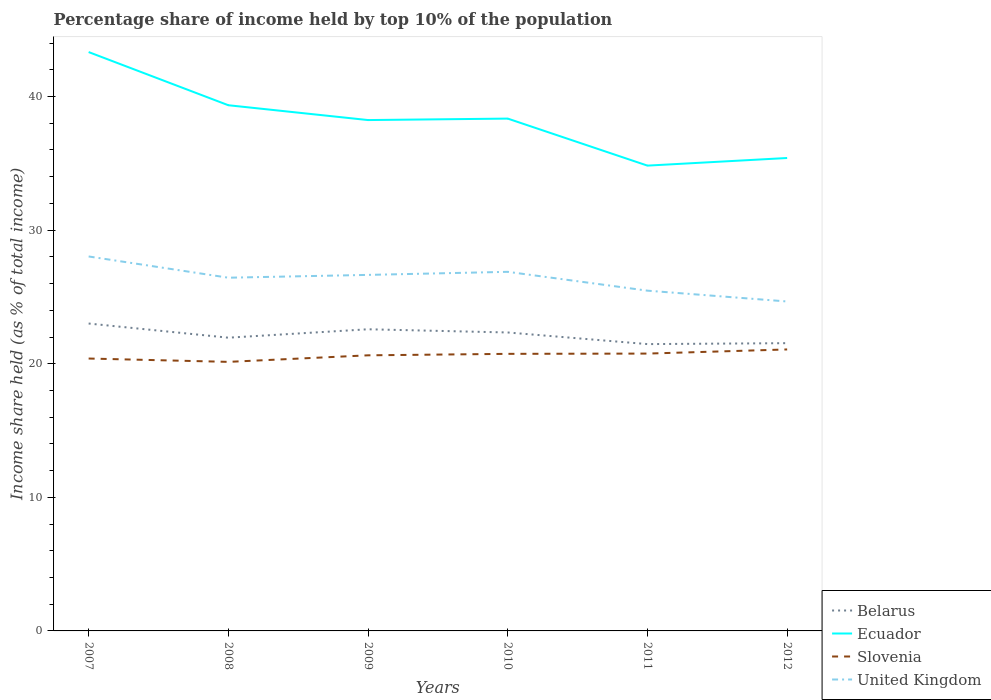How many different coloured lines are there?
Your response must be concise. 4. Does the line corresponding to Belarus intersect with the line corresponding to Ecuador?
Keep it short and to the point. No. Is the number of lines equal to the number of legend labels?
Your answer should be very brief. Yes. Across all years, what is the maximum percentage share of income held by top 10% of the population in United Kingdom?
Give a very brief answer. 24.66. In which year was the percentage share of income held by top 10% of the population in Belarus maximum?
Your response must be concise. 2011. What is the total percentage share of income held by top 10% of the population in Ecuador in the graph?
Give a very brief answer. 8.5. What is the difference between the highest and the second highest percentage share of income held by top 10% of the population in Belarus?
Provide a short and direct response. 1.54. What is the difference between the highest and the lowest percentage share of income held by top 10% of the population in Belarus?
Offer a terse response. 3. Is the percentage share of income held by top 10% of the population in Ecuador strictly greater than the percentage share of income held by top 10% of the population in Belarus over the years?
Make the answer very short. No. How many years are there in the graph?
Make the answer very short. 6. Are the values on the major ticks of Y-axis written in scientific E-notation?
Provide a short and direct response. No. Does the graph contain any zero values?
Offer a terse response. No. Does the graph contain grids?
Your answer should be compact. No. Where does the legend appear in the graph?
Your answer should be very brief. Bottom right. How many legend labels are there?
Your answer should be compact. 4. What is the title of the graph?
Ensure brevity in your answer.  Percentage share of income held by top 10% of the population. Does "Niger" appear as one of the legend labels in the graph?
Offer a terse response. No. What is the label or title of the X-axis?
Your answer should be compact. Years. What is the label or title of the Y-axis?
Offer a terse response. Income share held (as % of total income). What is the Income share held (as % of total income) in Belarus in 2007?
Provide a succinct answer. 23.01. What is the Income share held (as % of total income) in Ecuador in 2007?
Your answer should be very brief. 43.33. What is the Income share held (as % of total income) of Slovenia in 2007?
Your response must be concise. 20.39. What is the Income share held (as % of total income) of United Kingdom in 2007?
Provide a short and direct response. 28.03. What is the Income share held (as % of total income) of Belarus in 2008?
Make the answer very short. 21.95. What is the Income share held (as % of total income) of Ecuador in 2008?
Provide a short and direct response. 39.35. What is the Income share held (as % of total income) in Slovenia in 2008?
Offer a very short reply. 20.14. What is the Income share held (as % of total income) in United Kingdom in 2008?
Ensure brevity in your answer.  26.44. What is the Income share held (as % of total income) in Belarus in 2009?
Your response must be concise. 22.58. What is the Income share held (as % of total income) of Ecuador in 2009?
Offer a terse response. 38.24. What is the Income share held (as % of total income) in Slovenia in 2009?
Give a very brief answer. 20.63. What is the Income share held (as % of total income) of United Kingdom in 2009?
Offer a terse response. 26.65. What is the Income share held (as % of total income) of Belarus in 2010?
Offer a terse response. 22.34. What is the Income share held (as % of total income) in Ecuador in 2010?
Offer a terse response. 38.35. What is the Income share held (as % of total income) of Slovenia in 2010?
Your response must be concise. 20.74. What is the Income share held (as % of total income) of United Kingdom in 2010?
Your answer should be compact. 26.88. What is the Income share held (as % of total income) of Belarus in 2011?
Give a very brief answer. 21.47. What is the Income share held (as % of total income) in Ecuador in 2011?
Offer a terse response. 34.83. What is the Income share held (as % of total income) in Slovenia in 2011?
Give a very brief answer. 20.76. What is the Income share held (as % of total income) in United Kingdom in 2011?
Provide a succinct answer. 25.47. What is the Income share held (as % of total income) in Belarus in 2012?
Your answer should be very brief. 21.54. What is the Income share held (as % of total income) of Ecuador in 2012?
Keep it short and to the point. 35.4. What is the Income share held (as % of total income) in Slovenia in 2012?
Make the answer very short. 21.07. What is the Income share held (as % of total income) of United Kingdom in 2012?
Provide a short and direct response. 24.66. Across all years, what is the maximum Income share held (as % of total income) in Belarus?
Keep it short and to the point. 23.01. Across all years, what is the maximum Income share held (as % of total income) in Ecuador?
Offer a terse response. 43.33. Across all years, what is the maximum Income share held (as % of total income) in Slovenia?
Your answer should be very brief. 21.07. Across all years, what is the maximum Income share held (as % of total income) of United Kingdom?
Provide a succinct answer. 28.03. Across all years, what is the minimum Income share held (as % of total income) of Belarus?
Give a very brief answer. 21.47. Across all years, what is the minimum Income share held (as % of total income) of Ecuador?
Offer a terse response. 34.83. Across all years, what is the minimum Income share held (as % of total income) of Slovenia?
Your answer should be very brief. 20.14. Across all years, what is the minimum Income share held (as % of total income) of United Kingdom?
Your answer should be compact. 24.66. What is the total Income share held (as % of total income) in Belarus in the graph?
Provide a short and direct response. 132.89. What is the total Income share held (as % of total income) in Ecuador in the graph?
Offer a terse response. 229.5. What is the total Income share held (as % of total income) of Slovenia in the graph?
Provide a succinct answer. 123.73. What is the total Income share held (as % of total income) of United Kingdom in the graph?
Your answer should be compact. 158.13. What is the difference between the Income share held (as % of total income) in Belarus in 2007 and that in 2008?
Provide a succinct answer. 1.06. What is the difference between the Income share held (as % of total income) in Ecuador in 2007 and that in 2008?
Ensure brevity in your answer.  3.98. What is the difference between the Income share held (as % of total income) in Slovenia in 2007 and that in 2008?
Provide a succinct answer. 0.25. What is the difference between the Income share held (as % of total income) in United Kingdom in 2007 and that in 2008?
Offer a terse response. 1.59. What is the difference between the Income share held (as % of total income) of Belarus in 2007 and that in 2009?
Keep it short and to the point. 0.43. What is the difference between the Income share held (as % of total income) in Ecuador in 2007 and that in 2009?
Give a very brief answer. 5.09. What is the difference between the Income share held (as % of total income) in Slovenia in 2007 and that in 2009?
Your response must be concise. -0.24. What is the difference between the Income share held (as % of total income) in United Kingdom in 2007 and that in 2009?
Make the answer very short. 1.38. What is the difference between the Income share held (as % of total income) of Belarus in 2007 and that in 2010?
Your response must be concise. 0.67. What is the difference between the Income share held (as % of total income) in Ecuador in 2007 and that in 2010?
Give a very brief answer. 4.98. What is the difference between the Income share held (as % of total income) of Slovenia in 2007 and that in 2010?
Your answer should be compact. -0.35. What is the difference between the Income share held (as % of total income) in United Kingdom in 2007 and that in 2010?
Offer a very short reply. 1.15. What is the difference between the Income share held (as % of total income) in Belarus in 2007 and that in 2011?
Make the answer very short. 1.54. What is the difference between the Income share held (as % of total income) of Slovenia in 2007 and that in 2011?
Ensure brevity in your answer.  -0.37. What is the difference between the Income share held (as % of total income) of United Kingdom in 2007 and that in 2011?
Your response must be concise. 2.56. What is the difference between the Income share held (as % of total income) in Belarus in 2007 and that in 2012?
Make the answer very short. 1.47. What is the difference between the Income share held (as % of total income) in Ecuador in 2007 and that in 2012?
Provide a short and direct response. 7.93. What is the difference between the Income share held (as % of total income) in Slovenia in 2007 and that in 2012?
Your response must be concise. -0.68. What is the difference between the Income share held (as % of total income) of United Kingdom in 2007 and that in 2012?
Ensure brevity in your answer.  3.37. What is the difference between the Income share held (as % of total income) in Belarus in 2008 and that in 2009?
Make the answer very short. -0.63. What is the difference between the Income share held (as % of total income) of Ecuador in 2008 and that in 2009?
Your answer should be very brief. 1.11. What is the difference between the Income share held (as % of total income) of Slovenia in 2008 and that in 2009?
Your answer should be very brief. -0.49. What is the difference between the Income share held (as % of total income) of United Kingdom in 2008 and that in 2009?
Offer a very short reply. -0.21. What is the difference between the Income share held (as % of total income) of Belarus in 2008 and that in 2010?
Provide a short and direct response. -0.39. What is the difference between the Income share held (as % of total income) in United Kingdom in 2008 and that in 2010?
Your answer should be very brief. -0.44. What is the difference between the Income share held (as % of total income) of Belarus in 2008 and that in 2011?
Keep it short and to the point. 0.48. What is the difference between the Income share held (as % of total income) in Ecuador in 2008 and that in 2011?
Your response must be concise. 4.52. What is the difference between the Income share held (as % of total income) in Slovenia in 2008 and that in 2011?
Offer a terse response. -0.62. What is the difference between the Income share held (as % of total income) of United Kingdom in 2008 and that in 2011?
Give a very brief answer. 0.97. What is the difference between the Income share held (as % of total income) in Belarus in 2008 and that in 2012?
Provide a succinct answer. 0.41. What is the difference between the Income share held (as % of total income) in Ecuador in 2008 and that in 2012?
Keep it short and to the point. 3.95. What is the difference between the Income share held (as % of total income) of Slovenia in 2008 and that in 2012?
Offer a very short reply. -0.93. What is the difference between the Income share held (as % of total income) of United Kingdom in 2008 and that in 2012?
Make the answer very short. 1.78. What is the difference between the Income share held (as % of total income) of Belarus in 2009 and that in 2010?
Give a very brief answer. 0.24. What is the difference between the Income share held (as % of total income) of Ecuador in 2009 and that in 2010?
Provide a short and direct response. -0.11. What is the difference between the Income share held (as % of total income) in Slovenia in 2009 and that in 2010?
Offer a terse response. -0.11. What is the difference between the Income share held (as % of total income) of United Kingdom in 2009 and that in 2010?
Make the answer very short. -0.23. What is the difference between the Income share held (as % of total income) of Belarus in 2009 and that in 2011?
Offer a terse response. 1.11. What is the difference between the Income share held (as % of total income) of Ecuador in 2009 and that in 2011?
Offer a terse response. 3.41. What is the difference between the Income share held (as % of total income) of Slovenia in 2009 and that in 2011?
Offer a very short reply. -0.13. What is the difference between the Income share held (as % of total income) of United Kingdom in 2009 and that in 2011?
Provide a short and direct response. 1.18. What is the difference between the Income share held (as % of total income) in Ecuador in 2009 and that in 2012?
Provide a succinct answer. 2.84. What is the difference between the Income share held (as % of total income) of Slovenia in 2009 and that in 2012?
Your answer should be compact. -0.44. What is the difference between the Income share held (as % of total income) of United Kingdom in 2009 and that in 2012?
Your answer should be very brief. 1.99. What is the difference between the Income share held (as % of total income) of Belarus in 2010 and that in 2011?
Keep it short and to the point. 0.87. What is the difference between the Income share held (as % of total income) in Ecuador in 2010 and that in 2011?
Provide a succinct answer. 3.52. What is the difference between the Income share held (as % of total income) in Slovenia in 2010 and that in 2011?
Keep it short and to the point. -0.02. What is the difference between the Income share held (as % of total income) of United Kingdom in 2010 and that in 2011?
Make the answer very short. 1.41. What is the difference between the Income share held (as % of total income) of Ecuador in 2010 and that in 2012?
Ensure brevity in your answer.  2.95. What is the difference between the Income share held (as % of total income) in Slovenia in 2010 and that in 2012?
Offer a terse response. -0.33. What is the difference between the Income share held (as % of total income) of United Kingdom in 2010 and that in 2012?
Your response must be concise. 2.22. What is the difference between the Income share held (as % of total income) in Belarus in 2011 and that in 2012?
Your answer should be compact. -0.07. What is the difference between the Income share held (as % of total income) in Ecuador in 2011 and that in 2012?
Keep it short and to the point. -0.57. What is the difference between the Income share held (as % of total income) in Slovenia in 2011 and that in 2012?
Provide a succinct answer. -0.31. What is the difference between the Income share held (as % of total income) of United Kingdom in 2011 and that in 2012?
Keep it short and to the point. 0.81. What is the difference between the Income share held (as % of total income) of Belarus in 2007 and the Income share held (as % of total income) of Ecuador in 2008?
Your answer should be compact. -16.34. What is the difference between the Income share held (as % of total income) in Belarus in 2007 and the Income share held (as % of total income) in Slovenia in 2008?
Offer a very short reply. 2.87. What is the difference between the Income share held (as % of total income) of Belarus in 2007 and the Income share held (as % of total income) of United Kingdom in 2008?
Your answer should be compact. -3.43. What is the difference between the Income share held (as % of total income) of Ecuador in 2007 and the Income share held (as % of total income) of Slovenia in 2008?
Offer a very short reply. 23.19. What is the difference between the Income share held (as % of total income) in Ecuador in 2007 and the Income share held (as % of total income) in United Kingdom in 2008?
Keep it short and to the point. 16.89. What is the difference between the Income share held (as % of total income) in Slovenia in 2007 and the Income share held (as % of total income) in United Kingdom in 2008?
Offer a very short reply. -6.05. What is the difference between the Income share held (as % of total income) in Belarus in 2007 and the Income share held (as % of total income) in Ecuador in 2009?
Give a very brief answer. -15.23. What is the difference between the Income share held (as % of total income) in Belarus in 2007 and the Income share held (as % of total income) in Slovenia in 2009?
Ensure brevity in your answer.  2.38. What is the difference between the Income share held (as % of total income) in Belarus in 2007 and the Income share held (as % of total income) in United Kingdom in 2009?
Offer a very short reply. -3.64. What is the difference between the Income share held (as % of total income) of Ecuador in 2007 and the Income share held (as % of total income) of Slovenia in 2009?
Offer a very short reply. 22.7. What is the difference between the Income share held (as % of total income) in Ecuador in 2007 and the Income share held (as % of total income) in United Kingdom in 2009?
Your answer should be very brief. 16.68. What is the difference between the Income share held (as % of total income) of Slovenia in 2007 and the Income share held (as % of total income) of United Kingdom in 2009?
Offer a very short reply. -6.26. What is the difference between the Income share held (as % of total income) of Belarus in 2007 and the Income share held (as % of total income) of Ecuador in 2010?
Provide a succinct answer. -15.34. What is the difference between the Income share held (as % of total income) in Belarus in 2007 and the Income share held (as % of total income) in Slovenia in 2010?
Your response must be concise. 2.27. What is the difference between the Income share held (as % of total income) in Belarus in 2007 and the Income share held (as % of total income) in United Kingdom in 2010?
Provide a succinct answer. -3.87. What is the difference between the Income share held (as % of total income) in Ecuador in 2007 and the Income share held (as % of total income) in Slovenia in 2010?
Your response must be concise. 22.59. What is the difference between the Income share held (as % of total income) of Ecuador in 2007 and the Income share held (as % of total income) of United Kingdom in 2010?
Give a very brief answer. 16.45. What is the difference between the Income share held (as % of total income) of Slovenia in 2007 and the Income share held (as % of total income) of United Kingdom in 2010?
Offer a terse response. -6.49. What is the difference between the Income share held (as % of total income) in Belarus in 2007 and the Income share held (as % of total income) in Ecuador in 2011?
Keep it short and to the point. -11.82. What is the difference between the Income share held (as % of total income) of Belarus in 2007 and the Income share held (as % of total income) of Slovenia in 2011?
Your response must be concise. 2.25. What is the difference between the Income share held (as % of total income) of Belarus in 2007 and the Income share held (as % of total income) of United Kingdom in 2011?
Offer a terse response. -2.46. What is the difference between the Income share held (as % of total income) of Ecuador in 2007 and the Income share held (as % of total income) of Slovenia in 2011?
Provide a short and direct response. 22.57. What is the difference between the Income share held (as % of total income) in Ecuador in 2007 and the Income share held (as % of total income) in United Kingdom in 2011?
Keep it short and to the point. 17.86. What is the difference between the Income share held (as % of total income) of Slovenia in 2007 and the Income share held (as % of total income) of United Kingdom in 2011?
Keep it short and to the point. -5.08. What is the difference between the Income share held (as % of total income) of Belarus in 2007 and the Income share held (as % of total income) of Ecuador in 2012?
Provide a succinct answer. -12.39. What is the difference between the Income share held (as % of total income) in Belarus in 2007 and the Income share held (as % of total income) in Slovenia in 2012?
Make the answer very short. 1.94. What is the difference between the Income share held (as % of total income) of Belarus in 2007 and the Income share held (as % of total income) of United Kingdom in 2012?
Offer a very short reply. -1.65. What is the difference between the Income share held (as % of total income) in Ecuador in 2007 and the Income share held (as % of total income) in Slovenia in 2012?
Offer a terse response. 22.26. What is the difference between the Income share held (as % of total income) of Ecuador in 2007 and the Income share held (as % of total income) of United Kingdom in 2012?
Your answer should be compact. 18.67. What is the difference between the Income share held (as % of total income) of Slovenia in 2007 and the Income share held (as % of total income) of United Kingdom in 2012?
Provide a succinct answer. -4.27. What is the difference between the Income share held (as % of total income) of Belarus in 2008 and the Income share held (as % of total income) of Ecuador in 2009?
Give a very brief answer. -16.29. What is the difference between the Income share held (as % of total income) of Belarus in 2008 and the Income share held (as % of total income) of Slovenia in 2009?
Ensure brevity in your answer.  1.32. What is the difference between the Income share held (as % of total income) in Belarus in 2008 and the Income share held (as % of total income) in United Kingdom in 2009?
Your answer should be compact. -4.7. What is the difference between the Income share held (as % of total income) in Ecuador in 2008 and the Income share held (as % of total income) in Slovenia in 2009?
Give a very brief answer. 18.72. What is the difference between the Income share held (as % of total income) of Ecuador in 2008 and the Income share held (as % of total income) of United Kingdom in 2009?
Offer a terse response. 12.7. What is the difference between the Income share held (as % of total income) in Slovenia in 2008 and the Income share held (as % of total income) in United Kingdom in 2009?
Offer a very short reply. -6.51. What is the difference between the Income share held (as % of total income) of Belarus in 2008 and the Income share held (as % of total income) of Ecuador in 2010?
Your response must be concise. -16.4. What is the difference between the Income share held (as % of total income) in Belarus in 2008 and the Income share held (as % of total income) in Slovenia in 2010?
Ensure brevity in your answer.  1.21. What is the difference between the Income share held (as % of total income) of Belarus in 2008 and the Income share held (as % of total income) of United Kingdom in 2010?
Your answer should be very brief. -4.93. What is the difference between the Income share held (as % of total income) of Ecuador in 2008 and the Income share held (as % of total income) of Slovenia in 2010?
Your response must be concise. 18.61. What is the difference between the Income share held (as % of total income) in Ecuador in 2008 and the Income share held (as % of total income) in United Kingdom in 2010?
Your answer should be very brief. 12.47. What is the difference between the Income share held (as % of total income) in Slovenia in 2008 and the Income share held (as % of total income) in United Kingdom in 2010?
Give a very brief answer. -6.74. What is the difference between the Income share held (as % of total income) of Belarus in 2008 and the Income share held (as % of total income) of Ecuador in 2011?
Offer a very short reply. -12.88. What is the difference between the Income share held (as % of total income) in Belarus in 2008 and the Income share held (as % of total income) in Slovenia in 2011?
Your answer should be compact. 1.19. What is the difference between the Income share held (as % of total income) in Belarus in 2008 and the Income share held (as % of total income) in United Kingdom in 2011?
Provide a succinct answer. -3.52. What is the difference between the Income share held (as % of total income) of Ecuador in 2008 and the Income share held (as % of total income) of Slovenia in 2011?
Offer a terse response. 18.59. What is the difference between the Income share held (as % of total income) in Ecuador in 2008 and the Income share held (as % of total income) in United Kingdom in 2011?
Your response must be concise. 13.88. What is the difference between the Income share held (as % of total income) of Slovenia in 2008 and the Income share held (as % of total income) of United Kingdom in 2011?
Give a very brief answer. -5.33. What is the difference between the Income share held (as % of total income) of Belarus in 2008 and the Income share held (as % of total income) of Ecuador in 2012?
Offer a very short reply. -13.45. What is the difference between the Income share held (as % of total income) of Belarus in 2008 and the Income share held (as % of total income) of Slovenia in 2012?
Provide a short and direct response. 0.88. What is the difference between the Income share held (as % of total income) in Belarus in 2008 and the Income share held (as % of total income) in United Kingdom in 2012?
Provide a succinct answer. -2.71. What is the difference between the Income share held (as % of total income) of Ecuador in 2008 and the Income share held (as % of total income) of Slovenia in 2012?
Make the answer very short. 18.28. What is the difference between the Income share held (as % of total income) of Ecuador in 2008 and the Income share held (as % of total income) of United Kingdom in 2012?
Your answer should be very brief. 14.69. What is the difference between the Income share held (as % of total income) of Slovenia in 2008 and the Income share held (as % of total income) of United Kingdom in 2012?
Give a very brief answer. -4.52. What is the difference between the Income share held (as % of total income) of Belarus in 2009 and the Income share held (as % of total income) of Ecuador in 2010?
Provide a short and direct response. -15.77. What is the difference between the Income share held (as % of total income) in Belarus in 2009 and the Income share held (as % of total income) in Slovenia in 2010?
Keep it short and to the point. 1.84. What is the difference between the Income share held (as % of total income) of Ecuador in 2009 and the Income share held (as % of total income) of United Kingdom in 2010?
Provide a short and direct response. 11.36. What is the difference between the Income share held (as % of total income) of Slovenia in 2009 and the Income share held (as % of total income) of United Kingdom in 2010?
Provide a short and direct response. -6.25. What is the difference between the Income share held (as % of total income) in Belarus in 2009 and the Income share held (as % of total income) in Ecuador in 2011?
Make the answer very short. -12.25. What is the difference between the Income share held (as % of total income) in Belarus in 2009 and the Income share held (as % of total income) in Slovenia in 2011?
Keep it short and to the point. 1.82. What is the difference between the Income share held (as % of total income) of Belarus in 2009 and the Income share held (as % of total income) of United Kingdom in 2011?
Offer a terse response. -2.89. What is the difference between the Income share held (as % of total income) in Ecuador in 2009 and the Income share held (as % of total income) in Slovenia in 2011?
Offer a terse response. 17.48. What is the difference between the Income share held (as % of total income) in Ecuador in 2009 and the Income share held (as % of total income) in United Kingdom in 2011?
Your response must be concise. 12.77. What is the difference between the Income share held (as % of total income) of Slovenia in 2009 and the Income share held (as % of total income) of United Kingdom in 2011?
Provide a short and direct response. -4.84. What is the difference between the Income share held (as % of total income) of Belarus in 2009 and the Income share held (as % of total income) of Ecuador in 2012?
Provide a short and direct response. -12.82. What is the difference between the Income share held (as % of total income) in Belarus in 2009 and the Income share held (as % of total income) in Slovenia in 2012?
Provide a short and direct response. 1.51. What is the difference between the Income share held (as % of total income) in Belarus in 2009 and the Income share held (as % of total income) in United Kingdom in 2012?
Your answer should be compact. -2.08. What is the difference between the Income share held (as % of total income) of Ecuador in 2009 and the Income share held (as % of total income) of Slovenia in 2012?
Give a very brief answer. 17.17. What is the difference between the Income share held (as % of total income) of Ecuador in 2009 and the Income share held (as % of total income) of United Kingdom in 2012?
Provide a succinct answer. 13.58. What is the difference between the Income share held (as % of total income) of Slovenia in 2009 and the Income share held (as % of total income) of United Kingdom in 2012?
Keep it short and to the point. -4.03. What is the difference between the Income share held (as % of total income) of Belarus in 2010 and the Income share held (as % of total income) of Ecuador in 2011?
Your answer should be very brief. -12.49. What is the difference between the Income share held (as % of total income) in Belarus in 2010 and the Income share held (as % of total income) in Slovenia in 2011?
Your answer should be compact. 1.58. What is the difference between the Income share held (as % of total income) in Belarus in 2010 and the Income share held (as % of total income) in United Kingdom in 2011?
Provide a short and direct response. -3.13. What is the difference between the Income share held (as % of total income) of Ecuador in 2010 and the Income share held (as % of total income) of Slovenia in 2011?
Make the answer very short. 17.59. What is the difference between the Income share held (as % of total income) in Ecuador in 2010 and the Income share held (as % of total income) in United Kingdom in 2011?
Offer a terse response. 12.88. What is the difference between the Income share held (as % of total income) in Slovenia in 2010 and the Income share held (as % of total income) in United Kingdom in 2011?
Your answer should be very brief. -4.73. What is the difference between the Income share held (as % of total income) in Belarus in 2010 and the Income share held (as % of total income) in Ecuador in 2012?
Make the answer very short. -13.06. What is the difference between the Income share held (as % of total income) in Belarus in 2010 and the Income share held (as % of total income) in Slovenia in 2012?
Provide a succinct answer. 1.27. What is the difference between the Income share held (as % of total income) of Belarus in 2010 and the Income share held (as % of total income) of United Kingdom in 2012?
Your answer should be compact. -2.32. What is the difference between the Income share held (as % of total income) in Ecuador in 2010 and the Income share held (as % of total income) in Slovenia in 2012?
Provide a short and direct response. 17.28. What is the difference between the Income share held (as % of total income) of Ecuador in 2010 and the Income share held (as % of total income) of United Kingdom in 2012?
Your answer should be very brief. 13.69. What is the difference between the Income share held (as % of total income) in Slovenia in 2010 and the Income share held (as % of total income) in United Kingdom in 2012?
Your response must be concise. -3.92. What is the difference between the Income share held (as % of total income) of Belarus in 2011 and the Income share held (as % of total income) of Ecuador in 2012?
Your answer should be very brief. -13.93. What is the difference between the Income share held (as % of total income) of Belarus in 2011 and the Income share held (as % of total income) of United Kingdom in 2012?
Keep it short and to the point. -3.19. What is the difference between the Income share held (as % of total income) of Ecuador in 2011 and the Income share held (as % of total income) of Slovenia in 2012?
Keep it short and to the point. 13.76. What is the difference between the Income share held (as % of total income) of Ecuador in 2011 and the Income share held (as % of total income) of United Kingdom in 2012?
Provide a succinct answer. 10.17. What is the average Income share held (as % of total income) in Belarus per year?
Ensure brevity in your answer.  22.15. What is the average Income share held (as % of total income) of Ecuador per year?
Your answer should be very brief. 38.25. What is the average Income share held (as % of total income) in Slovenia per year?
Provide a succinct answer. 20.62. What is the average Income share held (as % of total income) in United Kingdom per year?
Provide a short and direct response. 26.36. In the year 2007, what is the difference between the Income share held (as % of total income) in Belarus and Income share held (as % of total income) in Ecuador?
Offer a terse response. -20.32. In the year 2007, what is the difference between the Income share held (as % of total income) in Belarus and Income share held (as % of total income) in Slovenia?
Your response must be concise. 2.62. In the year 2007, what is the difference between the Income share held (as % of total income) in Belarus and Income share held (as % of total income) in United Kingdom?
Your response must be concise. -5.02. In the year 2007, what is the difference between the Income share held (as % of total income) of Ecuador and Income share held (as % of total income) of Slovenia?
Ensure brevity in your answer.  22.94. In the year 2007, what is the difference between the Income share held (as % of total income) of Ecuador and Income share held (as % of total income) of United Kingdom?
Your answer should be compact. 15.3. In the year 2007, what is the difference between the Income share held (as % of total income) in Slovenia and Income share held (as % of total income) in United Kingdom?
Your response must be concise. -7.64. In the year 2008, what is the difference between the Income share held (as % of total income) of Belarus and Income share held (as % of total income) of Ecuador?
Your answer should be compact. -17.4. In the year 2008, what is the difference between the Income share held (as % of total income) of Belarus and Income share held (as % of total income) of Slovenia?
Provide a short and direct response. 1.81. In the year 2008, what is the difference between the Income share held (as % of total income) of Belarus and Income share held (as % of total income) of United Kingdom?
Provide a succinct answer. -4.49. In the year 2008, what is the difference between the Income share held (as % of total income) of Ecuador and Income share held (as % of total income) of Slovenia?
Offer a very short reply. 19.21. In the year 2008, what is the difference between the Income share held (as % of total income) in Ecuador and Income share held (as % of total income) in United Kingdom?
Your answer should be compact. 12.91. In the year 2008, what is the difference between the Income share held (as % of total income) in Slovenia and Income share held (as % of total income) in United Kingdom?
Provide a succinct answer. -6.3. In the year 2009, what is the difference between the Income share held (as % of total income) of Belarus and Income share held (as % of total income) of Ecuador?
Keep it short and to the point. -15.66. In the year 2009, what is the difference between the Income share held (as % of total income) of Belarus and Income share held (as % of total income) of Slovenia?
Ensure brevity in your answer.  1.95. In the year 2009, what is the difference between the Income share held (as % of total income) in Belarus and Income share held (as % of total income) in United Kingdom?
Keep it short and to the point. -4.07. In the year 2009, what is the difference between the Income share held (as % of total income) of Ecuador and Income share held (as % of total income) of Slovenia?
Keep it short and to the point. 17.61. In the year 2009, what is the difference between the Income share held (as % of total income) in Ecuador and Income share held (as % of total income) in United Kingdom?
Your response must be concise. 11.59. In the year 2009, what is the difference between the Income share held (as % of total income) in Slovenia and Income share held (as % of total income) in United Kingdom?
Give a very brief answer. -6.02. In the year 2010, what is the difference between the Income share held (as % of total income) in Belarus and Income share held (as % of total income) in Ecuador?
Make the answer very short. -16.01. In the year 2010, what is the difference between the Income share held (as % of total income) in Belarus and Income share held (as % of total income) in United Kingdom?
Your response must be concise. -4.54. In the year 2010, what is the difference between the Income share held (as % of total income) in Ecuador and Income share held (as % of total income) in Slovenia?
Offer a terse response. 17.61. In the year 2010, what is the difference between the Income share held (as % of total income) in Ecuador and Income share held (as % of total income) in United Kingdom?
Provide a short and direct response. 11.47. In the year 2010, what is the difference between the Income share held (as % of total income) of Slovenia and Income share held (as % of total income) of United Kingdom?
Ensure brevity in your answer.  -6.14. In the year 2011, what is the difference between the Income share held (as % of total income) of Belarus and Income share held (as % of total income) of Ecuador?
Offer a very short reply. -13.36. In the year 2011, what is the difference between the Income share held (as % of total income) in Belarus and Income share held (as % of total income) in Slovenia?
Give a very brief answer. 0.71. In the year 2011, what is the difference between the Income share held (as % of total income) in Ecuador and Income share held (as % of total income) in Slovenia?
Keep it short and to the point. 14.07. In the year 2011, what is the difference between the Income share held (as % of total income) in Ecuador and Income share held (as % of total income) in United Kingdom?
Your answer should be very brief. 9.36. In the year 2011, what is the difference between the Income share held (as % of total income) in Slovenia and Income share held (as % of total income) in United Kingdom?
Ensure brevity in your answer.  -4.71. In the year 2012, what is the difference between the Income share held (as % of total income) in Belarus and Income share held (as % of total income) in Ecuador?
Ensure brevity in your answer.  -13.86. In the year 2012, what is the difference between the Income share held (as % of total income) of Belarus and Income share held (as % of total income) of Slovenia?
Provide a short and direct response. 0.47. In the year 2012, what is the difference between the Income share held (as % of total income) in Belarus and Income share held (as % of total income) in United Kingdom?
Ensure brevity in your answer.  -3.12. In the year 2012, what is the difference between the Income share held (as % of total income) in Ecuador and Income share held (as % of total income) in Slovenia?
Keep it short and to the point. 14.33. In the year 2012, what is the difference between the Income share held (as % of total income) of Ecuador and Income share held (as % of total income) of United Kingdom?
Your answer should be very brief. 10.74. In the year 2012, what is the difference between the Income share held (as % of total income) of Slovenia and Income share held (as % of total income) of United Kingdom?
Give a very brief answer. -3.59. What is the ratio of the Income share held (as % of total income) of Belarus in 2007 to that in 2008?
Make the answer very short. 1.05. What is the ratio of the Income share held (as % of total income) of Ecuador in 2007 to that in 2008?
Offer a terse response. 1.1. What is the ratio of the Income share held (as % of total income) in Slovenia in 2007 to that in 2008?
Keep it short and to the point. 1.01. What is the ratio of the Income share held (as % of total income) in United Kingdom in 2007 to that in 2008?
Make the answer very short. 1.06. What is the ratio of the Income share held (as % of total income) of Ecuador in 2007 to that in 2009?
Provide a short and direct response. 1.13. What is the ratio of the Income share held (as % of total income) in Slovenia in 2007 to that in 2009?
Ensure brevity in your answer.  0.99. What is the ratio of the Income share held (as % of total income) in United Kingdom in 2007 to that in 2009?
Give a very brief answer. 1.05. What is the ratio of the Income share held (as % of total income) of Ecuador in 2007 to that in 2010?
Provide a succinct answer. 1.13. What is the ratio of the Income share held (as % of total income) of Slovenia in 2007 to that in 2010?
Your answer should be compact. 0.98. What is the ratio of the Income share held (as % of total income) in United Kingdom in 2007 to that in 2010?
Offer a very short reply. 1.04. What is the ratio of the Income share held (as % of total income) in Belarus in 2007 to that in 2011?
Offer a terse response. 1.07. What is the ratio of the Income share held (as % of total income) in Ecuador in 2007 to that in 2011?
Offer a very short reply. 1.24. What is the ratio of the Income share held (as % of total income) in Slovenia in 2007 to that in 2011?
Offer a terse response. 0.98. What is the ratio of the Income share held (as % of total income) in United Kingdom in 2007 to that in 2011?
Ensure brevity in your answer.  1.1. What is the ratio of the Income share held (as % of total income) of Belarus in 2007 to that in 2012?
Provide a short and direct response. 1.07. What is the ratio of the Income share held (as % of total income) in Ecuador in 2007 to that in 2012?
Provide a succinct answer. 1.22. What is the ratio of the Income share held (as % of total income) of United Kingdom in 2007 to that in 2012?
Your answer should be very brief. 1.14. What is the ratio of the Income share held (as % of total income) in Belarus in 2008 to that in 2009?
Provide a succinct answer. 0.97. What is the ratio of the Income share held (as % of total income) in Slovenia in 2008 to that in 2009?
Keep it short and to the point. 0.98. What is the ratio of the Income share held (as % of total income) in United Kingdom in 2008 to that in 2009?
Keep it short and to the point. 0.99. What is the ratio of the Income share held (as % of total income) in Belarus in 2008 to that in 2010?
Your answer should be compact. 0.98. What is the ratio of the Income share held (as % of total income) of Ecuador in 2008 to that in 2010?
Make the answer very short. 1.03. What is the ratio of the Income share held (as % of total income) in Slovenia in 2008 to that in 2010?
Provide a short and direct response. 0.97. What is the ratio of the Income share held (as % of total income) in United Kingdom in 2008 to that in 2010?
Offer a very short reply. 0.98. What is the ratio of the Income share held (as % of total income) in Belarus in 2008 to that in 2011?
Give a very brief answer. 1.02. What is the ratio of the Income share held (as % of total income) of Ecuador in 2008 to that in 2011?
Give a very brief answer. 1.13. What is the ratio of the Income share held (as % of total income) in Slovenia in 2008 to that in 2011?
Give a very brief answer. 0.97. What is the ratio of the Income share held (as % of total income) of United Kingdom in 2008 to that in 2011?
Offer a terse response. 1.04. What is the ratio of the Income share held (as % of total income) of Ecuador in 2008 to that in 2012?
Give a very brief answer. 1.11. What is the ratio of the Income share held (as % of total income) in Slovenia in 2008 to that in 2012?
Your response must be concise. 0.96. What is the ratio of the Income share held (as % of total income) of United Kingdom in 2008 to that in 2012?
Your response must be concise. 1.07. What is the ratio of the Income share held (as % of total income) in Belarus in 2009 to that in 2010?
Give a very brief answer. 1.01. What is the ratio of the Income share held (as % of total income) in Ecuador in 2009 to that in 2010?
Your answer should be very brief. 1. What is the ratio of the Income share held (as % of total income) in Slovenia in 2009 to that in 2010?
Offer a terse response. 0.99. What is the ratio of the Income share held (as % of total income) of Belarus in 2009 to that in 2011?
Provide a succinct answer. 1.05. What is the ratio of the Income share held (as % of total income) in Ecuador in 2009 to that in 2011?
Ensure brevity in your answer.  1.1. What is the ratio of the Income share held (as % of total income) in United Kingdom in 2009 to that in 2011?
Give a very brief answer. 1.05. What is the ratio of the Income share held (as % of total income) of Belarus in 2009 to that in 2012?
Provide a short and direct response. 1.05. What is the ratio of the Income share held (as % of total income) in Ecuador in 2009 to that in 2012?
Provide a short and direct response. 1.08. What is the ratio of the Income share held (as % of total income) in Slovenia in 2009 to that in 2012?
Offer a very short reply. 0.98. What is the ratio of the Income share held (as % of total income) in United Kingdom in 2009 to that in 2012?
Give a very brief answer. 1.08. What is the ratio of the Income share held (as % of total income) in Belarus in 2010 to that in 2011?
Ensure brevity in your answer.  1.04. What is the ratio of the Income share held (as % of total income) in Ecuador in 2010 to that in 2011?
Your answer should be very brief. 1.1. What is the ratio of the Income share held (as % of total income) in Slovenia in 2010 to that in 2011?
Your response must be concise. 1. What is the ratio of the Income share held (as % of total income) in United Kingdom in 2010 to that in 2011?
Give a very brief answer. 1.06. What is the ratio of the Income share held (as % of total income) in Belarus in 2010 to that in 2012?
Give a very brief answer. 1.04. What is the ratio of the Income share held (as % of total income) in Slovenia in 2010 to that in 2012?
Give a very brief answer. 0.98. What is the ratio of the Income share held (as % of total income) of United Kingdom in 2010 to that in 2012?
Give a very brief answer. 1.09. What is the ratio of the Income share held (as % of total income) of Belarus in 2011 to that in 2012?
Make the answer very short. 1. What is the ratio of the Income share held (as % of total income) of Ecuador in 2011 to that in 2012?
Your response must be concise. 0.98. What is the ratio of the Income share held (as % of total income) of Slovenia in 2011 to that in 2012?
Provide a short and direct response. 0.99. What is the ratio of the Income share held (as % of total income) in United Kingdom in 2011 to that in 2012?
Your response must be concise. 1.03. What is the difference between the highest and the second highest Income share held (as % of total income) of Belarus?
Provide a short and direct response. 0.43. What is the difference between the highest and the second highest Income share held (as % of total income) in Ecuador?
Ensure brevity in your answer.  3.98. What is the difference between the highest and the second highest Income share held (as % of total income) in Slovenia?
Make the answer very short. 0.31. What is the difference between the highest and the second highest Income share held (as % of total income) of United Kingdom?
Keep it short and to the point. 1.15. What is the difference between the highest and the lowest Income share held (as % of total income) in Belarus?
Make the answer very short. 1.54. What is the difference between the highest and the lowest Income share held (as % of total income) in Slovenia?
Offer a very short reply. 0.93. What is the difference between the highest and the lowest Income share held (as % of total income) in United Kingdom?
Keep it short and to the point. 3.37. 